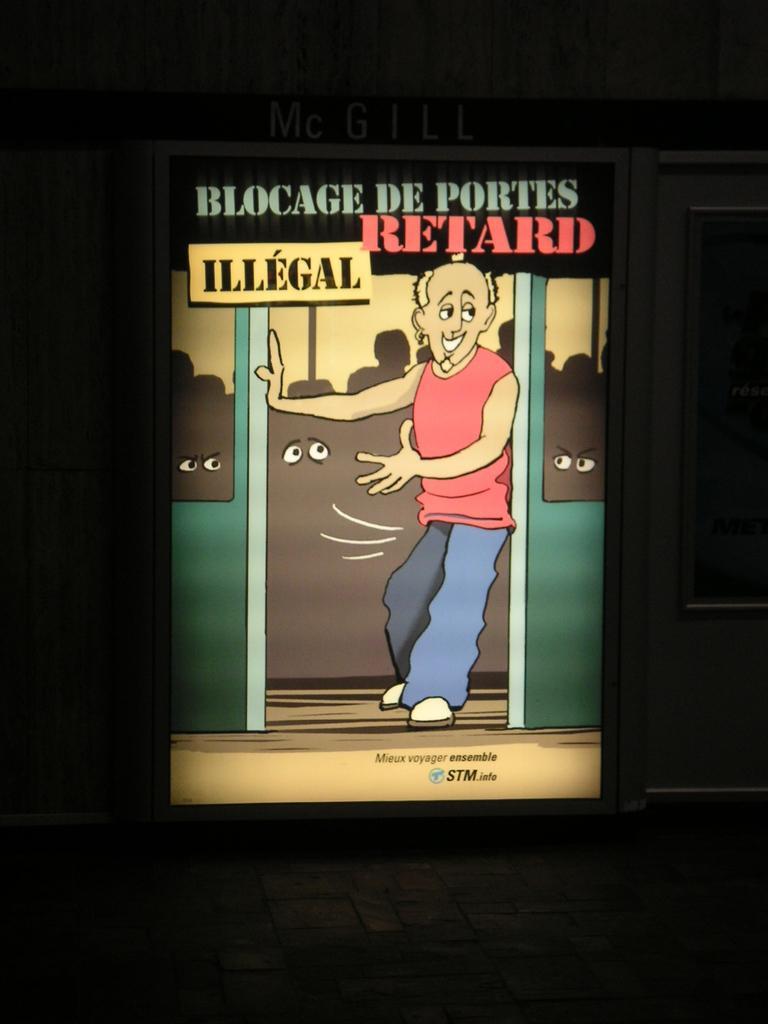Can you describe this image briefly? This is the picture of a posture in which there is a person and something written on it. 